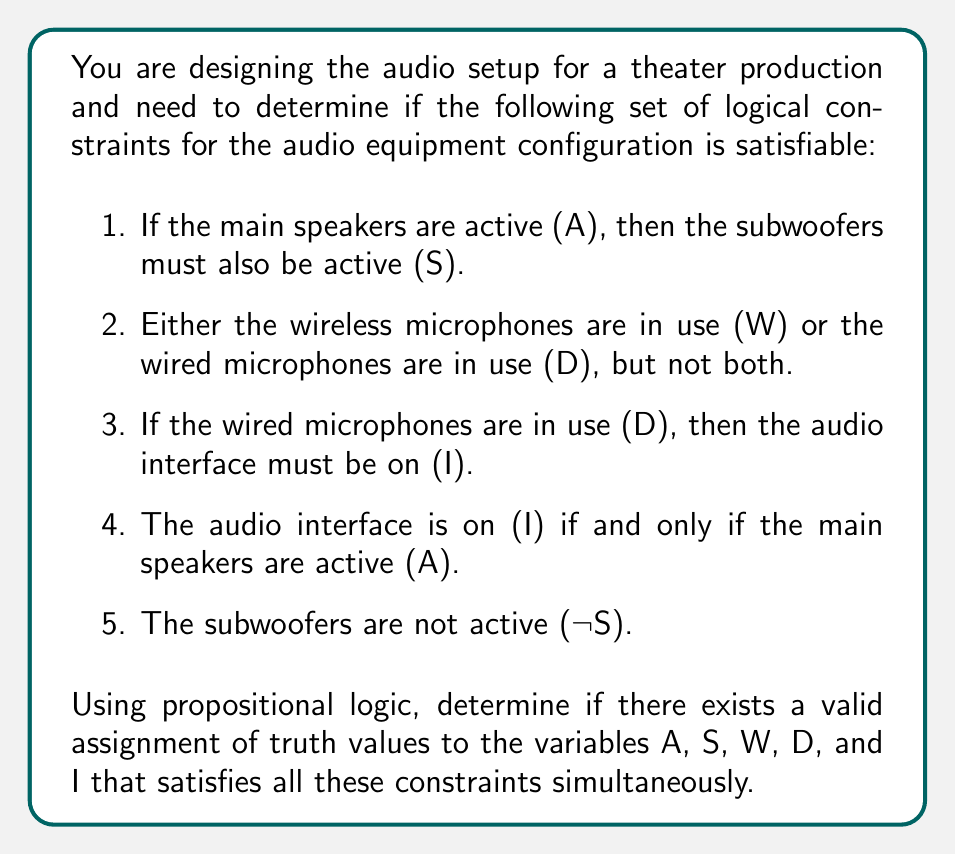Can you answer this question? Let's approach this step-by-step using propositional logic:

1. First, let's formalize the constraints using logical operators:
   a. $A \implies S$
   b. $(W \lor D) \land \lnot(W \land D)$
   c. $D \implies I$
   d. $A \iff I$
   e. $\lnot S$

2. We'll use the method of contradiction. Assume all constraints can be satisfied, and then try to derive a contradiction.

3. From constraint (e), we know that S must be false.

4. Given that S is false, and using constraint (a), we can deduce that A must also be false. If A were true, it would imply S is true, contradicting (e).

5. Since A is false, from constraint (d), we can conclude that I must also be false.

6. Now, let's consider constraint (b). Either W or D must be true, but not both.

7. If D were true, then by constraint (c), I would have to be true. However, we already established that I is false. Therefore, D must be false.

8. Since D is false, and exactly one of W or D must be true (from constraint b), we can conclude that W must be true.

9. At this point, we have a consistent assignment:
   A: False
   S: False
   W: True
   D: False
   I: False

10. This assignment satisfies all the constraints:
    a. $False \implies False$ (vacuously true)
    b. $(True \lor False) \land \lnot(True \land False)$ is true
    c. $False \implies False$ (vacuously true)
    d. $False \iff False$ is true
    e. $\lnot False$ is true

Therefore, the set of constraints is satisfiable.
Answer: Yes, the set of logical constraints is satisfiable. A valid assignment of truth values is:
A: False, S: False, W: True, D: False, I: False 